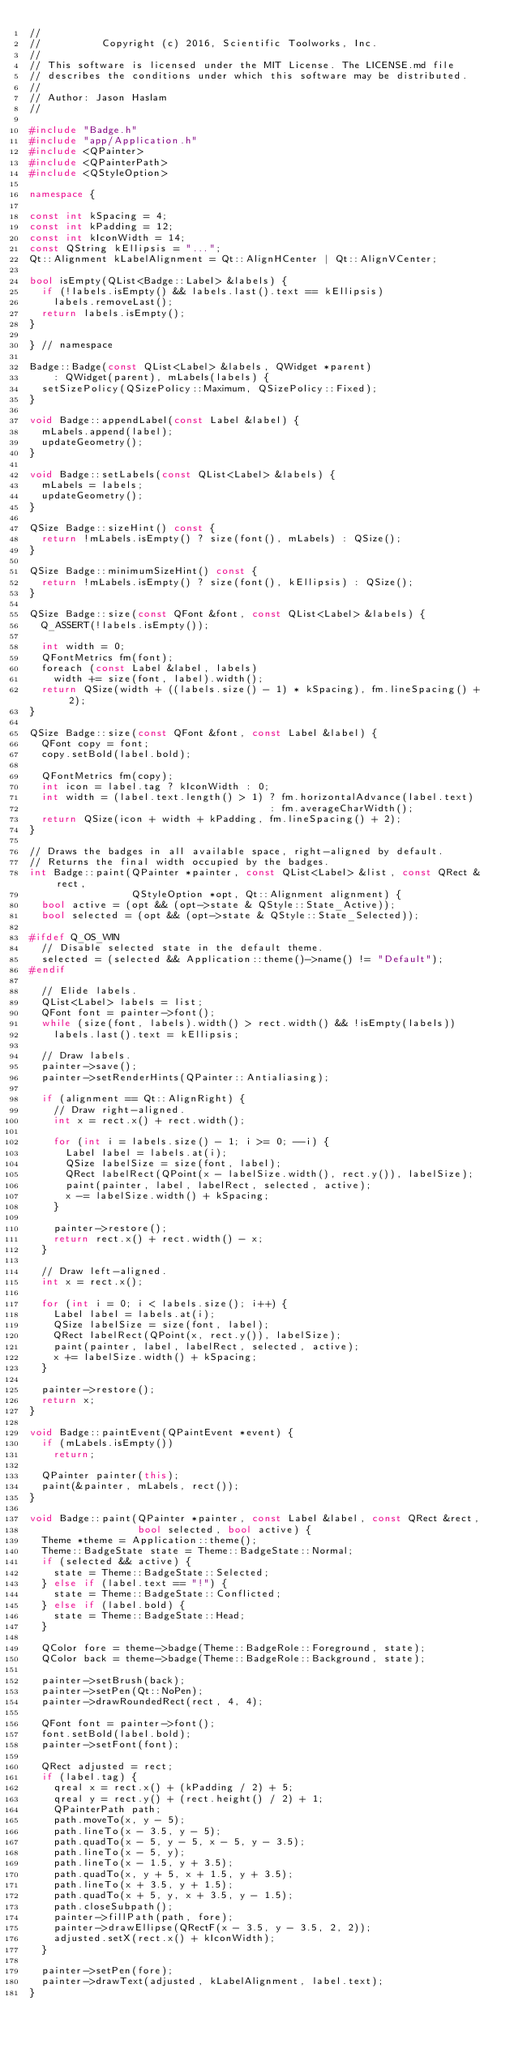<code> <loc_0><loc_0><loc_500><loc_500><_C++_>//
//          Copyright (c) 2016, Scientific Toolworks, Inc.
//
// This software is licensed under the MIT License. The LICENSE.md file
// describes the conditions under which this software may be distributed.
//
// Author: Jason Haslam
//

#include "Badge.h"
#include "app/Application.h"
#include <QPainter>
#include <QPainterPath>
#include <QStyleOption>

namespace {

const int kSpacing = 4;
const int kPadding = 12;
const int kIconWidth = 14;
const QString kEllipsis = "...";
Qt::Alignment kLabelAlignment = Qt::AlignHCenter | Qt::AlignVCenter;

bool isEmpty(QList<Badge::Label> &labels) {
  if (!labels.isEmpty() && labels.last().text == kEllipsis)
    labels.removeLast();
  return labels.isEmpty();
}

} // namespace

Badge::Badge(const QList<Label> &labels, QWidget *parent)
    : QWidget(parent), mLabels(labels) {
  setSizePolicy(QSizePolicy::Maximum, QSizePolicy::Fixed);
}

void Badge::appendLabel(const Label &label) {
  mLabels.append(label);
  updateGeometry();
}

void Badge::setLabels(const QList<Label> &labels) {
  mLabels = labels;
  updateGeometry();
}

QSize Badge::sizeHint() const {
  return !mLabels.isEmpty() ? size(font(), mLabels) : QSize();
}

QSize Badge::minimumSizeHint() const {
  return !mLabels.isEmpty() ? size(font(), kEllipsis) : QSize();
}

QSize Badge::size(const QFont &font, const QList<Label> &labels) {
  Q_ASSERT(!labels.isEmpty());

  int width = 0;
  QFontMetrics fm(font);
  foreach (const Label &label, labels)
    width += size(font, label).width();
  return QSize(width + ((labels.size() - 1) * kSpacing), fm.lineSpacing() + 2);
}

QSize Badge::size(const QFont &font, const Label &label) {
  QFont copy = font;
  copy.setBold(label.bold);

  QFontMetrics fm(copy);
  int icon = label.tag ? kIconWidth : 0;
  int width = (label.text.length() > 1) ? fm.horizontalAdvance(label.text)
                                        : fm.averageCharWidth();
  return QSize(icon + width + kPadding, fm.lineSpacing() + 2);
}

// Draws the badges in all available space, right-aligned by default.
// Returns the final width occupied by the badges.
int Badge::paint(QPainter *painter, const QList<Label> &list, const QRect &rect,
                 QStyleOption *opt, Qt::Alignment alignment) {
  bool active = (opt && (opt->state & QStyle::State_Active));
  bool selected = (opt && (opt->state & QStyle::State_Selected));

#ifdef Q_OS_WIN
  // Disable selected state in the default theme.
  selected = (selected && Application::theme()->name() != "Default");
#endif

  // Elide labels.
  QList<Label> labels = list;
  QFont font = painter->font();
  while (size(font, labels).width() > rect.width() && !isEmpty(labels))
    labels.last().text = kEllipsis;

  // Draw labels.
  painter->save();
  painter->setRenderHints(QPainter::Antialiasing);

  if (alignment == Qt::AlignRight) {
    // Draw right-aligned.
    int x = rect.x() + rect.width();

    for (int i = labels.size() - 1; i >= 0; --i) {
      Label label = labels.at(i);
      QSize labelSize = size(font, label);
      QRect labelRect(QPoint(x - labelSize.width(), rect.y()), labelSize);
      paint(painter, label, labelRect, selected, active);
      x -= labelSize.width() + kSpacing;
    }

    painter->restore();
    return rect.x() + rect.width() - x;
  }

  // Draw left-aligned.
  int x = rect.x();

  for (int i = 0; i < labels.size(); i++) {
    Label label = labels.at(i);
    QSize labelSize = size(font, label);
    QRect labelRect(QPoint(x, rect.y()), labelSize);
    paint(painter, label, labelRect, selected, active);
    x += labelSize.width() + kSpacing;
  }

  painter->restore();
  return x;
}

void Badge::paintEvent(QPaintEvent *event) {
  if (mLabels.isEmpty())
    return;

  QPainter painter(this);
  paint(&painter, mLabels, rect());
}

void Badge::paint(QPainter *painter, const Label &label, const QRect &rect,
                  bool selected, bool active) {
  Theme *theme = Application::theme();
  Theme::BadgeState state = Theme::BadgeState::Normal;
  if (selected && active) {
    state = Theme::BadgeState::Selected;
  } else if (label.text == "!") {
    state = Theme::BadgeState::Conflicted;
  } else if (label.bold) {
    state = Theme::BadgeState::Head;
  }

  QColor fore = theme->badge(Theme::BadgeRole::Foreground, state);
  QColor back = theme->badge(Theme::BadgeRole::Background, state);

  painter->setBrush(back);
  painter->setPen(Qt::NoPen);
  painter->drawRoundedRect(rect, 4, 4);

  QFont font = painter->font();
  font.setBold(label.bold);
  painter->setFont(font);

  QRect adjusted = rect;
  if (label.tag) {
    qreal x = rect.x() + (kPadding / 2) + 5;
    qreal y = rect.y() + (rect.height() / 2) + 1;
    QPainterPath path;
    path.moveTo(x, y - 5);
    path.lineTo(x - 3.5, y - 5);
    path.quadTo(x - 5, y - 5, x - 5, y - 3.5);
    path.lineTo(x - 5, y);
    path.lineTo(x - 1.5, y + 3.5);
    path.quadTo(x, y + 5, x + 1.5, y + 3.5);
    path.lineTo(x + 3.5, y + 1.5);
    path.quadTo(x + 5, y, x + 3.5, y - 1.5);
    path.closeSubpath();
    painter->fillPath(path, fore);
    painter->drawEllipse(QRectF(x - 3.5, y - 3.5, 2, 2));
    adjusted.setX(rect.x() + kIconWidth);
  }

  painter->setPen(fore);
  painter->drawText(adjusted, kLabelAlignment, label.text);
}
</code> 